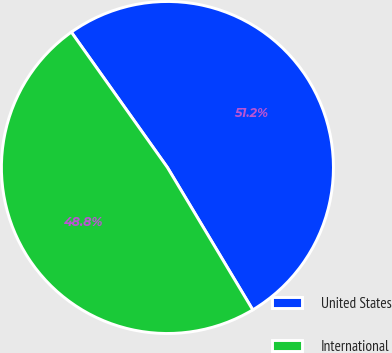<chart> <loc_0><loc_0><loc_500><loc_500><pie_chart><fcel>United States<fcel>International<nl><fcel>51.23%<fcel>48.77%<nl></chart> 